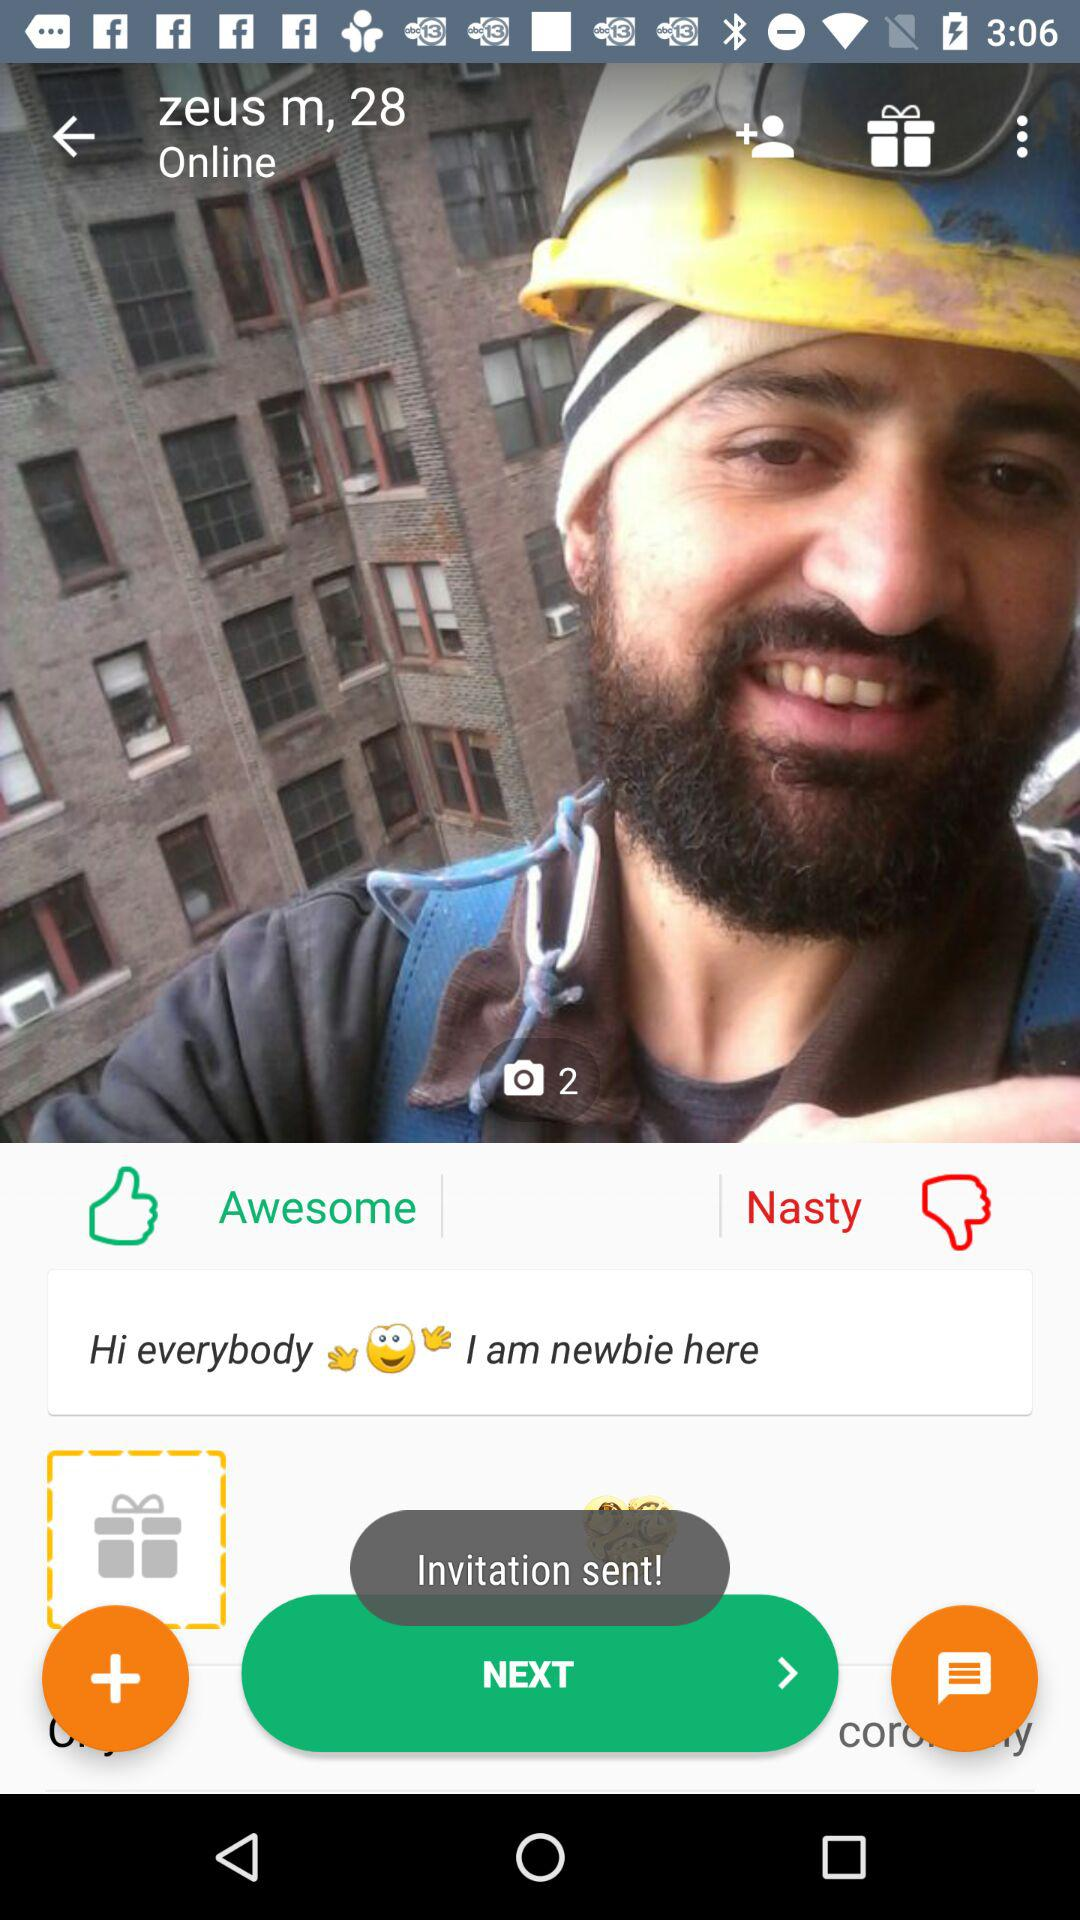What is the gender of the user? The gender is male. 